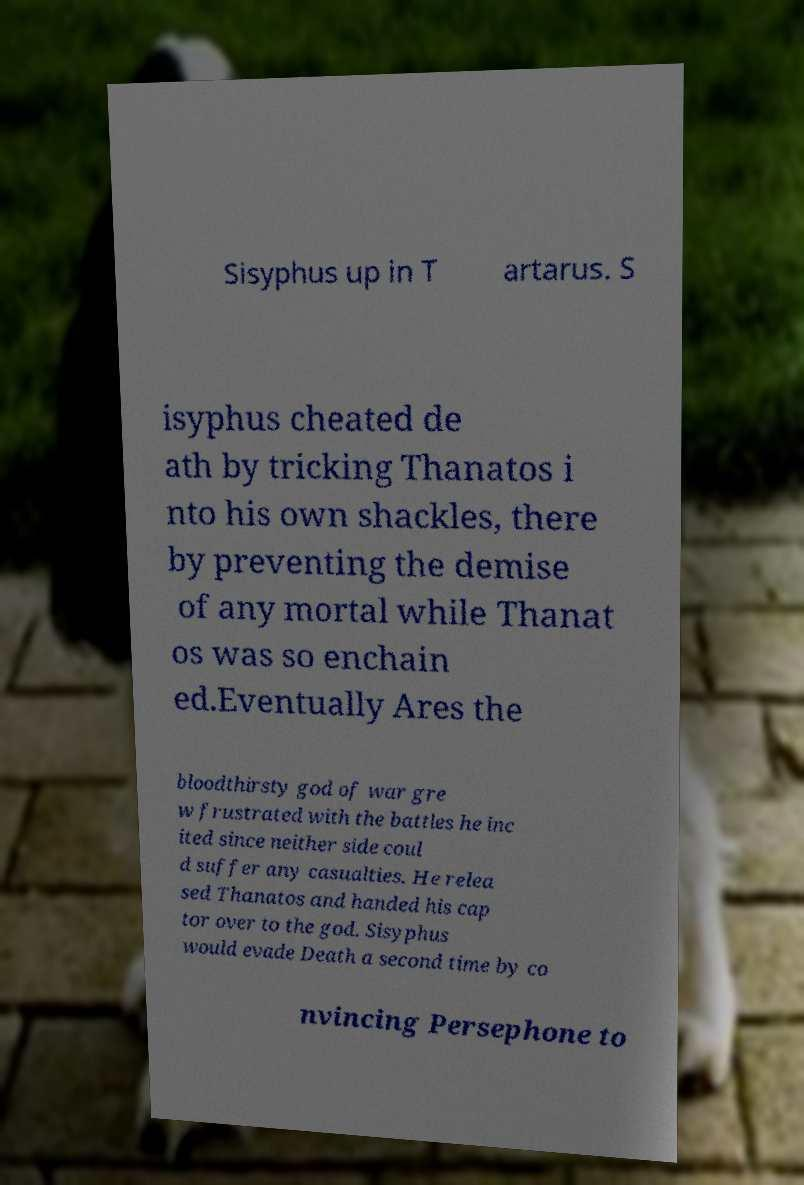Could you extract and type out the text from this image? Sisyphus up in T artarus. S isyphus cheated de ath by tricking Thanatos i nto his own shackles, there by preventing the demise of any mortal while Thanat os was so enchain ed.Eventually Ares the bloodthirsty god of war gre w frustrated with the battles he inc ited since neither side coul d suffer any casualties. He relea sed Thanatos and handed his cap tor over to the god. Sisyphus would evade Death a second time by co nvincing Persephone to 